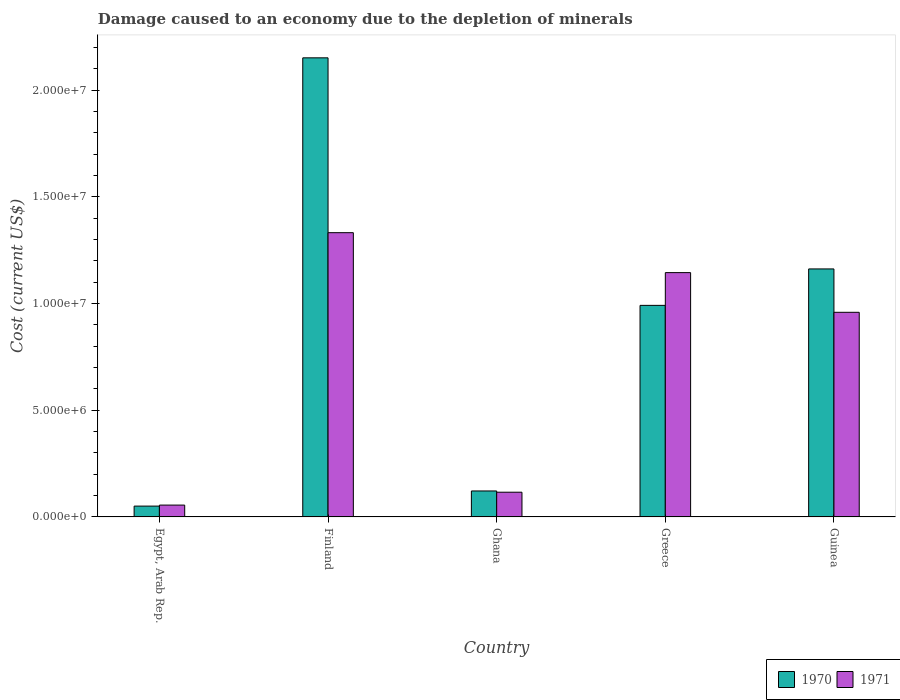How many different coloured bars are there?
Offer a terse response. 2. Are the number of bars on each tick of the X-axis equal?
Provide a short and direct response. Yes. What is the label of the 4th group of bars from the left?
Offer a terse response. Greece. What is the cost of damage caused due to the depletion of minerals in 1970 in Guinea?
Keep it short and to the point. 1.16e+07. Across all countries, what is the maximum cost of damage caused due to the depletion of minerals in 1971?
Make the answer very short. 1.33e+07. Across all countries, what is the minimum cost of damage caused due to the depletion of minerals in 1971?
Make the answer very short. 5.55e+05. In which country was the cost of damage caused due to the depletion of minerals in 1970 maximum?
Keep it short and to the point. Finland. In which country was the cost of damage caused due to the depletion of minerals in 1971 minimum?
Offer a terse response. Egypt, Arab Rep. What is the total cost of damage caused due to the depletion of minerals in 1971 in the graph?
Ensure brevity in your answer.  3.61e+07. What is the difference between the cost of damage caused due to the depletion of minerals in 1970 in Finland and that in Ghana?
Ensure brevity in your answer.  2.03e+07. What is the difference between the cost of damage caused due to the depletion of minerals in 1970 in Ghana and the cost of damage caused due to the depletion of minerals in 1971 in Egypt, Arab Rep.?
Provide a succinct answer. 6.62e+05. What is the average cost of damage caused due to the depletion of minerals in 1971 per country?
Offer a very short reply. 7.22e+06. What is the difference between the cost of damage caused due to the depletion of minerals of/in 1970 and cost of damage caused due to the depletion of minerals of/in 1971 in Egypt, Arab Rep.?
Your answer should be compact. -4.79e+04. What is the ratio of the cost of damage caused due to the depletion of minerals in 1970 in Ghana to that in Greece?
Provide a short and direct response. 0.12. What is the difference between the highest and the second highest cost of damage caused due to the depletion of minerals in 1971?
Your response must be concise. 1.87e+06. What is the difference between the highest and the lowest cost of damage caused due to the depletion of minerals in 1971?
Offer a terse response. 1.28e+07. In how many countries, is the cost of damage caused due to the depletion of minerals in 1971 greater than the average cost of damage caused due to the depletion of minerals in 1971 taken over all countries?
Make the answer very short. 3. Is the sum of the cost of damage caused due to the depletion of minerals in 1970 in Ghana and Guinea greater than the maximum cost of damage caused due to the depletion of minerals in 1971 across all countries?
Offer a very short reply. No. How many bars are there?
Your answer should be very brief. 10. Are all the bars in the graph horizontal?
Offer a very short reply. No. How many countries are there in the graph?
Provide a short and direct response. 5. Are the values on the major ticks of Y-axis written in scientific E-notation?
Offer a very short reply. Yes. Does the graph contain any zero values?
Keep it short and to the point. No. Where does the legend appear in the graph?
Your answer should be compact. Bottom right. How are the legend labels stacked?
Your answer should be very brief. Horizontal. What is the title of the graph?
Your response must be concise. Damage caused to an economy due to the depletion of minerals. What is the label or title of the Y-axis?
Provide a short and direct response. Cost (current US$). What is the Cost (current US$) of 1970 in Egypt, Arab Rep.?
Provide a succinct answer. 5.07e+05. What is the Cost (current US$) of 1971 in Egypt, Arab Rep.?
Your answer should be compact. 5.55e+05. What is the Cost (current US$) of 1970 in Finland?
Your response must be concise. 2.15e+07. What is the Cost (current US$) in 1971 in Finland?
Your answer should be very brief. 1.33e+07. What is the Cost (current US$) of 1970 in Ghana?
Provide a short and direct response. 1.22e+06. What is the Cost (current US$) in 1971 in Ghana?
Offer a terse response. 1.16e+06. What is the Cost (current US$) in 1970 in Greece?
Ensure brevity in your answer.  9.92e+06. What is the Cost (current US$) of 1971 in Greece?
Offer a very short reply. 1.15e+07. What is the Cost (current US$) in 1970 in Guinea?
Ensure brevity in your answer.  1.16e+07. What is the Cost (current US$) in 1971 in Guinea?
Provide a short and direct response. 9.59e+06. Across all countries, what is the maximum Cost (current US$) of 1970?
Ensure brevity in your answer.  2.15e+07. Across all countries, what is the maximum Cost (current US$) in 1971?
Your response must be concise. 1.33e+07. Across all countries, what is the minimum Cost (current US$) of 1970?
Ensure brevity in your answer.  5.07e+05. Across all countries, what is the minimum Cost (current US$) of 1971?
Your answer should be very brief. 5.55e+05. What is the total Cost (current US$) of 1970 in the graph?
Your response must be concise. 4.48e+07. What is the total Cost (current US$) in 1971 in the graph?
Offer a very short reply. 3.61e+07. What is the difference between the Cost (current US$) in 1970 in Egypt, Arab Rep. and that in Finland?
Give a very brief answer. -2.10e+07. What is the difference between the Cost (current US$) of 1971 in Egypt, Arab Rep. and that in Finland?
Your answer should be compact. -1.28e+07. What is the difference between the Cost (current US$) of 1970 in Egypt, Arab Rep. and that in Ghana?
Your answer should be compact. -7.10e+05. What is the difference between the Cost (current US$) of 1971 in Egypt, Arab Rep. and that in Ghana?
Make the answer very short. -6.03e+05. What is the difference between the Cost (current US$) in 1970 in Egypt, Arab Rep. and that in Greece?
Make the answer very short. -9.41e+06. What is the difference between the Cost (current US$) of 1971 in Egypt, Arab Rep. and that in Greece?
Provide a short and direct response. -1.09e+07. What is the difference between the Cost (current US$) in 1970 in Egypt, Arab Rep. and that in Guinea?
Your response must be concise. -1.11e+07. What is the difference between the Cost (current US$) of 1971 in Egypt, Arab Rep. and that in Guinea?
Offer a very short reply. -9.04e+06. What is the difference between the Cost (current US$) in 1970 in Finland and that in Ghana?
Offer a terse response. 2.03e+07. What is the difference between the Cost (current US$) in 1971 in Finland and that in Ghana?
Provide a short and direct response. 1.22e+07. What is the difference between the Cost (current US$) of 1970 in Finland and that in Greece?
Your answer should be compact. 1.16e+07. What is the difference between the Cost (current US$) of 1971 in Finland and that in Greece?
Provide a short and direct response. 1.87e+06. What is the difference between the Cost (current US$) of 1970 in Finland and that in Guinea?
Your answer should be compact. 9.89e+06. What is the difference between the Cost (current US$) in 1971 in Finland and that in Guinea?
Ensure brevity in your answer.  3.73e+06. What is the difference between the Cost (current US$) of 1970 in Ghana and that in Greece?
Offer a very short reply. -8.70e+06. What is the difference between the Cost (current US$) in 1971 in Ghana and that in Greece?
Give a very brief answer. -1.03e+07. What is the difference between the Cost (current US$) of 1970 in Ghana and that in Guinea?
Offer a terse response. -1.04e+07. What is the difference between the Cost (current US$) in 1971 in Ghana and that in Guinea?
Offer a very short reply. -8.43e+06. What is the difference between the Cost (current US$) in 1970 in Greece and that in Guinea?
Your answer should be compact. -1.71e+06. What is the difference between the Cost (current US$) in 1971 in Greece and that in Guinea?
Offer a very short reply. 1.86e+06. What is the difference between the Cost (current US$) in 1970 in Egypt, Arab Rep. and the Cost (current US$) in 1971 in Finland?
Make the answer very short. -1.28e+07. What is the difference between the Cost (current US$) in 1970 in Egypt, Arab Rep. and the Cost (current US$) in 1971 in Ghana?
Keep it short and to the point. -6.51e+05. What is the difference between the Cost (current US$) of 1970 in Egypt, Arab Rep. and the Cost (current US$) of 1971 in Greece?
Offer a terse response. -1.09e+07. What is the difference between the Cost (current US$) of 1970 in Egypt, Arab Rep. and the Cost (current US$) of 1971 in Guinea?
Give a very brief answer. -9.08e+06. What is the difference between the Cost (current US$) in 1970 in Finland and the Cost (current US$) in 1971 in Ghana?
Provide a succinct answer. 2.04e+07. What is the difference between the Cost (current US$) in 1970 in Finland and the Cost (current US$) in 1971 in Greece?
Offer a terse response. 1.01e+07. What is the difference between the Cost (current US$) in 1970 in Finland and the Cost (current US$) in 1971 in Guinea?
Your response must be concise. 1.19e+07. What is the difference between the Cost (current US$) in 1970 in Ghana and the Cost (current US$) in 1971 in Greece?
Provide a succinct answer. -1.02e+07. What is the difference between the Cost (current US$) of 1970 in Ghana and the Cost (current US$) of 1971 in Guinea?
Give a very brief answer. -8.37e+06. What is the difference between the Cost (current US$) of 1970 in Greece and the Cost (current US$) of 1971 in Guinea?
Give a very brief answer. 3.26e+05. What is the average Cost (current US$) in 1970 per country?
Provide a short and direct response. 8.96e+06. What is the average Cost (current US$) of 1971 per country?
Offer a very short reply. 7.22e+06. What is the difference between the Cost (current US$) in 1970 and Cost (current US$) in 1971 in Egypt, Arab Rep.?
Make the answer very short. -4.79e+04. What is the difference between the Cost (current US$) in 1970 and Cost (current US$) in 1971 in Finland?
Your response must be concise. 8.20e+06. What is the difference between the Cost (current US$) of 1970 and Cost (current US$) of 1971 in Ghana?
Your response must be concise. 5.86e+04. What is the difference between the Cost (current US$) in 1970 and Cost (current US$) in 1971 in Greece?
Provide a succinct answer. -1.53e+06. What is the difference between the Cost (current US$) in 1970 and Cost (current US$) in 1971 in Guinea?
Make the answer very short. 2.03e+06. What is the ratio of the Cost (current US$) in 1970 in Egypt, Arab Rep. to that in Finland?
Your answer should be very brief. 0.02. What is the ratio of the Cost (current US$) of 1971 in Egypt, Arab Rep. to that in Finland?
Keep it short and to the point. 0.04. What is the ratio of the Cost (current US$) in 1970 in Egypt, Arab Rep. to that in Ghana?
Give a very brief answer. 0.42. What is the ratio of the Cost (current US$) in 1971 in Egypt, Arab Rep. to that in Ghana?
Provide a succinct answer. 0.48. What is the ratio of the Cost (current US$) of 1970 in Egypt, Arab Rep. to that in Greece?
Make the answer very short. 0.05. What is the ratio of the Cost (current US$) in 1971 in Egypt, Arab Rep. to that in Greece?
Provide a succinct answer. 0.05. What is the ratio of the Cost (current US$) in 1970 in Egypt, Arab Rep. to that in Guinea?
Make the answer very short. 0.04. What is the ratio of the Cost (current US$) of 1971 in Egypt, Arab Rep. to that in Guinea?
Offer a very short reply. 0.06. What is the ratio of the Cost (current US$) of 1970 in Finland to that in Ghana?
Offer a very short reply. 17.68. What is the ratio of the Cost (current US$) in 1971 in Finland to that in Ghana?
Offer a very short reply. 11.5. What is the ratio of the Cost (current US$) in 1970 in Finland to that in Greece?
Ensure brevity in your answer.  2.17. What is the ratio of the Cost (current US$) of 1971 in Finland to that in Greece?
Provide a succinct answer. 1.16. What is the ratio of the Cost (current US$) in 1970 in Finland to that in Guinea?
Offer a very short reply. 1.85. What is the ratio of the Cost (current US$) of 1971 in Finland to that in Guinea?
Your response must be concise. 1.39. What is the ratio of the Cost (current US$) in 1970 in Ghana to that in Greece?
Your response must be concise. 0.12. What is the ratio of the Cost (current US$) in 1971 in Ghana to that in Greece?
Provide a succinct answer. 0.1. What is the ratio of the Cost (current US$) in 1970 in Ghana to that in Guinea?
Make the answer very short. 0.1. What is the ratio of the Cost (current US$) of 1971 in Ghana to that in Guinea?
Provide a succinct answer. 0.12. What is the ratio of the Cost (current US$) in 1970 in Greece to that in Guinea?
Keep it short and to the point. 0.85. What is the ratio of the Cost (current US$) in 1971 in Greece to that in Guinea?
Give a very brief answer. 1.19. What is the difference between the highest and the second highest Cost (current US$) of 1970?
Provide a short and direct response. 9.89e+06. What is the difference between the highest and the second highest Cost (current US$) of 1971?
Provide a short and direct response. 1.87e+06. What is the difference between the highest and the lowest Cost (current US$) of 1970?
Provide a succinct answer. 2.10e+07. What is the difference between the highest and the lowest Cost (current US$) in 1971?
Ensure brevity in your answer.  1.28e+07. 